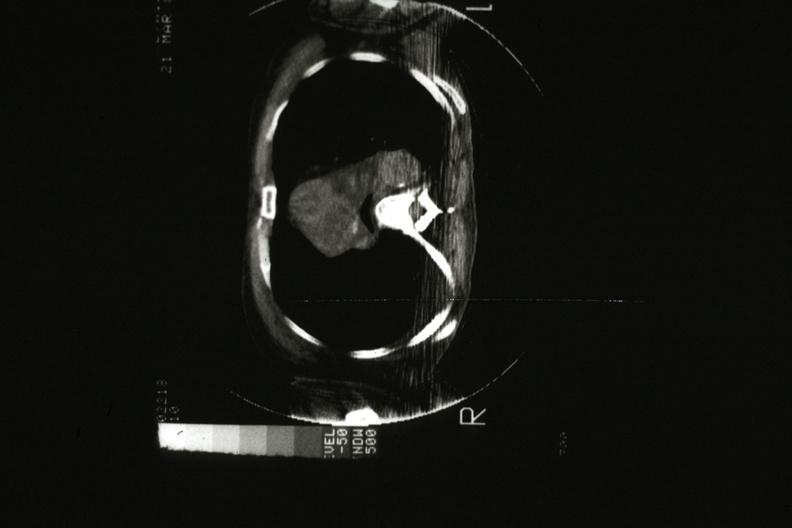s malignant thymoma present?
Answer the question using a single word or phrase. Yes 